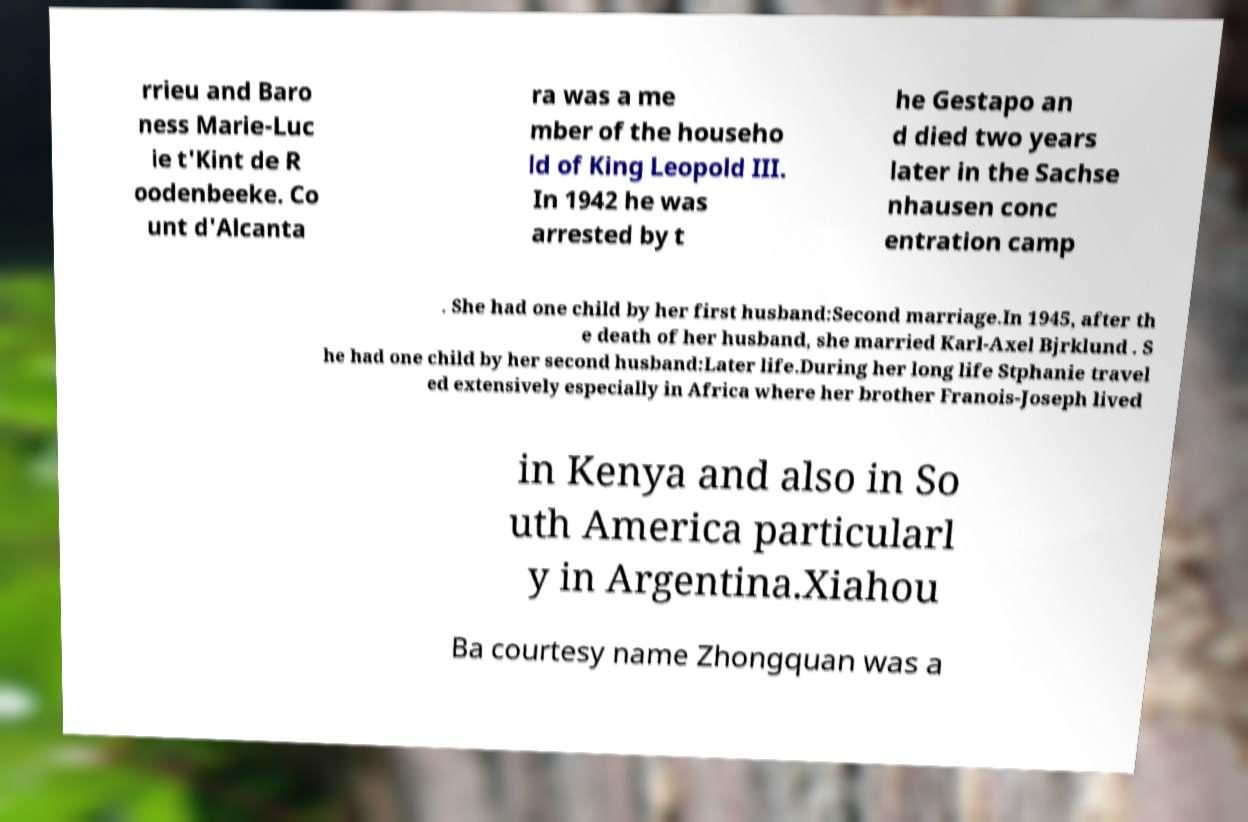Could you assist in decoding the text presented in this image and type it out clearly? rrieu and Baro ness Marie-Luc ie t'Kint de R oodenbeeke. Co unt d'Alcanta ra was a me mber of the househo ld of King Leopold III. In 1942 he was arrested by t he Gestapo an d died two years later in the Sachse nhausen conc entration camp . She had one child by her first husband:Second marriage.In 1945, after th e death of her husband, she married Karl-Axel Bjrklund . S he had one child by her second husband:Later life.During her long life Stphanie travel ed extensively especially in Africa where her brother Franois-Joseph lived in Kenya and also in So uth America particularl y in Argentina.Xiahou Ba courtesy name Zhongquan was a 